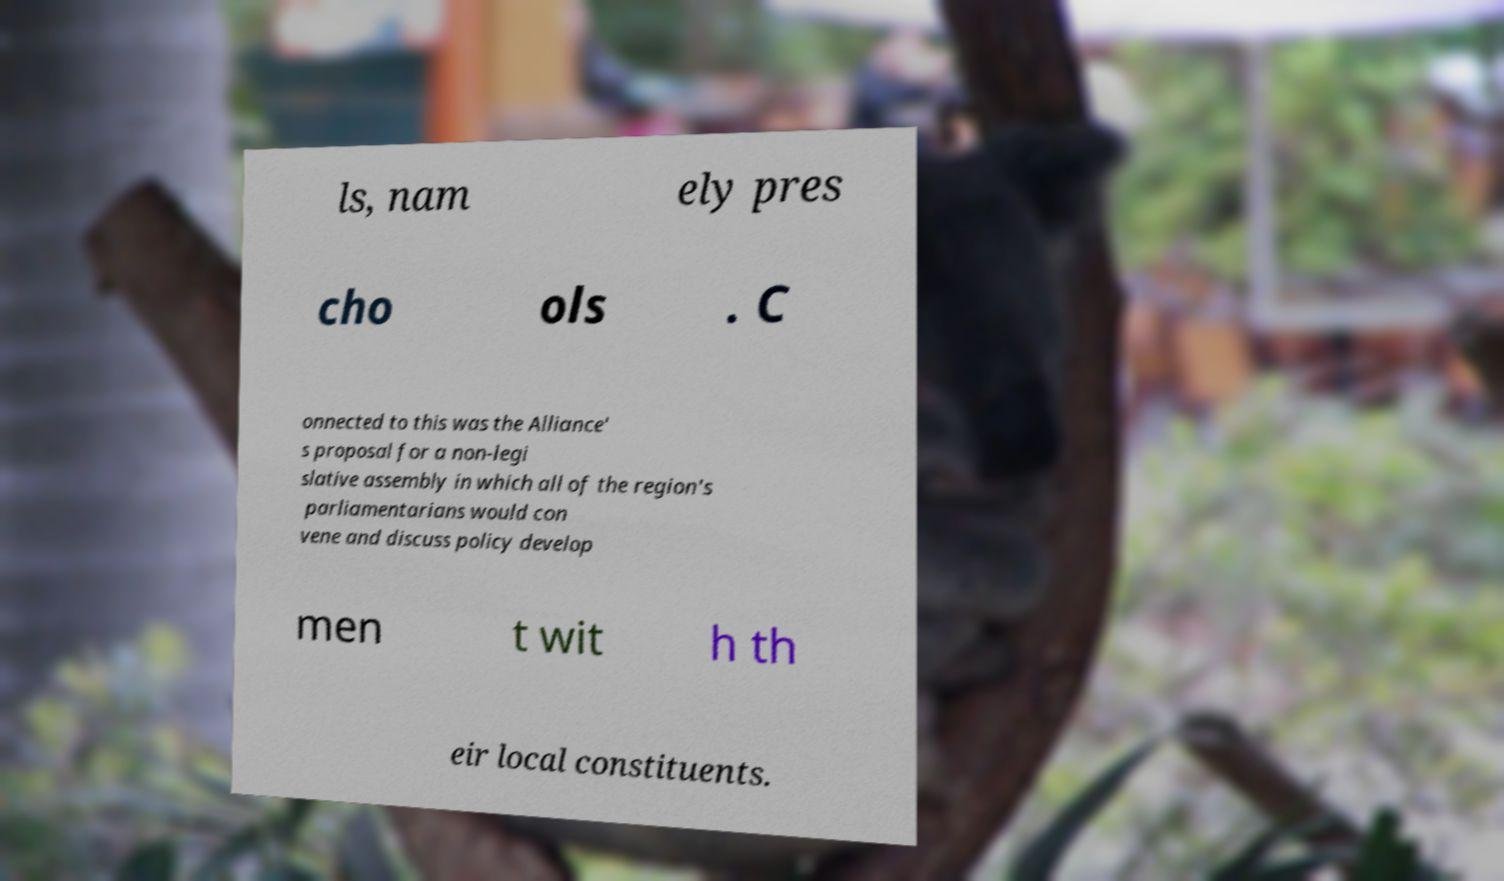Please read and relay the text visible in this image. What does it say? ls, nam ely pres cho ols . C onnected to this was the Alliance' s proposal for a non-legi slative assembly in which all of the region's parliamentarians would con vene and discuss policy develop men t wit h th eir local constituents. 